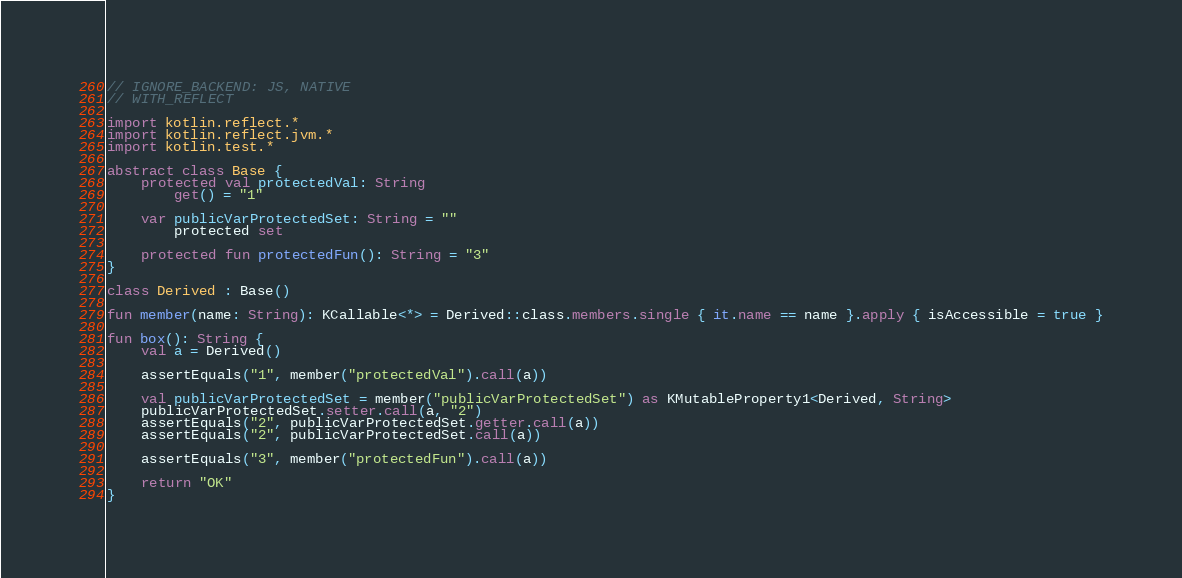Convert code to text. <code><loc_0><loc_0><loc_500><loc_500><_Kotlin_>// IGNORE_BACKEND: JS, NATIVE
// WITH_REFLECT

import kotlin.reflect.*
import kotlin.reflect.jvm.*
import kotlin.test.*

abstract class Base {
    protected val protectedVal: String
        get() = "1"

    var publicVarProtectedSet: String = ""
        protected set

    protected fun protectedFun(): String = "3"
}

class Derived : Base()

fun member(name: String): KCallable<*> = Derived::class.members.single { it.name == name }.apply { isAccessible = true }

fun box(): String {
    val a = Derived()

    assertEquals("1", member("protectedVal").call(a))

    val publicVarProtectedSet = member("publicVarProtectedSet") as KMutableProperty1<Derived, String>
    publicVarProtectedSet.setter.call(a, "2")
    assertEquals("2", publicVarProtectedSet.getter.call(a))
    assertEquals("2", publicVarProtectedSet.call(a))

    assertEquals("3", member("protectedFun").call(a))

    return "OK"
}
</code> 